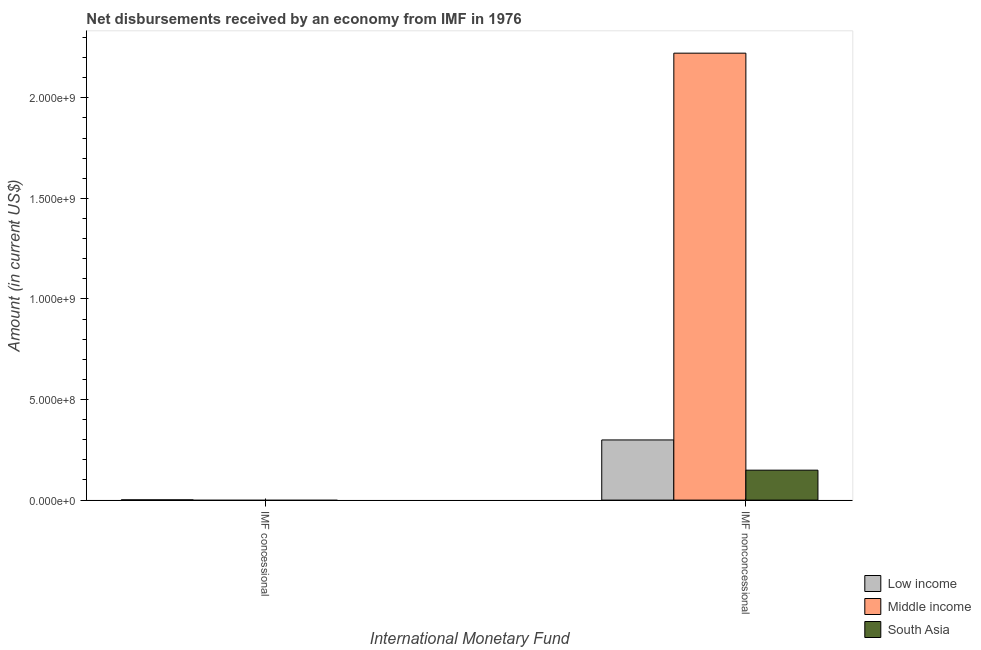How many different coloured bars are there?
Your response must be concise. 3. Are the number of bars on each tick of the X-axis equal?
Provide a short and direct response. No. How many bars are there on the 2nd tick from the left?
Provide a short and direct response. 3. What is the label of the 2nd group of bars from the left?
Provide a succinct answer. IMF nonconcessional. What is the net non concessional disbursements from imf in Middle income?
Offer a terse response. 2.22e+09. Across all countries, what is the maximum net concessional disbursements from imf?
Your answer should be compact. 1.18e+06. What is the total net concessional disbursements from imf in the graph?
Ensure brevity in your answer.  1.18e+06. What is the difference between the net non concessional disbursements from imf in Middle income and that in South Asia?
Give a very brief answer. 2.07e+09. What is the difference between the net non concessional disbursements from imf in Low income and the net concessional disbursements from imf in Middle income?
Make the answer very short. 2.99e+08. What is the average net non concessional disbursements from imf per country?
Keep it short and to the point. 8.90e+08. What is the difference between the net concessional disbursements from imf and net non concessional disbursements from imf in Low income?
Your answer should be compact. -2.98e+08. In how many countries, is the net non concessional disbursements from imf greater than 500000000 US$?
Offer a very short reply. 1. What is the ratio of the net non concessional disbursements from imf in Low income to that in Middle income?
Keep it short and to the point. 0.13. How many bars are there?
Offer a terse response. 4. Are all the bars in the graph horizontal?
Provide a succinct answer. No. How many countries are there in the graph?
Offer a terse response. 3. What is the difference between two consecutive major ticks on the Y-axis?
Give a very brief answer. 5.00e+08. Does the graph contain grids?
Your answer should be very brief. No. What is the title of the graph?
Your answer should be very brief. Net disbursements received by an economy from IMF in 1976. Does "St. Vincent and the Grenadines" appear as one of the legend labels in the graph?
Your answer should be compact. No. What is the label or title of the X-axis?
Make the answer very short. International Monetary Fund. What is the Amount (in current US$) of Low income in IMF concessional?
Offer a terse response. 1.18e+06. What is the Amount (in current US$) in Middle income in IMF concessional?
Provide a short and direct response. 0. What is the Amount (in current US$) of Low income in IMF nonconcessional?
Give a very brief answer. 2.99e+08. What is the Amount (in current US$) of Middle income in IMF nonconcessional?
Provide a short and direct response. 2.22e+09. What is the Amount (in current US$) of South Asia in IMF nonconcessional?
Give a very brief answer. 1.49e+08. Across all International Monetary Fund, what is the maximum Amount (in current US$) in Low income?
Provide a succinct answer. 2.99e+08. Across all International Monetary Fund, what is the maximum Amount (in current US$) of Middle income?
Your answer should be very brief. 2.22e+09. Across all International Monetary Fund, what is the maximum Amount (in current US$) in South Asia?
Provide a short and direct response. 1.49e+08. Across all International Monetary Fund, what is the minimum Amount (in current US$) in Low income?
Keep it short and to the point. 1.18e+06. What is the total Amount (in current US$) in Low income in the graph?
Ensure brevity in your answer.  3.00e+08. What is the total Amount (in current US$) in Middle income in the graph?
Make the answer very short. 2.22e+09. What is the total Amount (in current US$) in South Asia in the graph?
Keep it short and to the point. 1.49e+08. What is the difference between the Amount (in current US$) of Low income in IMF concessional and that in IMF nonconcessional?
Your response must be concise. -2.98e+08. What is the difference between the Amount (in current US$) of Low income in IMF concessional and the Amount (in current US$) of Middle income in IMF nonconcessional?
Make the answer very short. -2.22e+09. What is the difference between the Amount (in current US$) of Low income in IMF concessional and the Amount (in current US$) of South Asia in IMF nonconcessional?
Provide a succinct answer. -1.48e+08. What is the average Amount (in current US$) of Low income per International Monetary Fund?
Your answer should be very brief. 1.50e+08. What is the average Amount (in current US$) in Middle income per International Monetary Fund?
Keep it short and to the point. 1.11e+09. What is the average Amount (in current US$) of South Asia per International Monetary Fund?
Keep it short and to the point. 7.44e+07. What is the difference between the Amount (in current US$) of Low income and Amount (in current US$) of Middle income in IMF nonconcessional?
Offer a terse response. -1.92e+09. What is the difference between the Amount (in current US$) of Low income and Amount (in current US$) of South Asia in IMF nonconcessional?
Give a very brief answer. 1.50e+08. What is the difference between the Amount (in current US$) in Middle income and Amount (in current US$) in South Asia in IMF nonconcessional?
Provide a short and direct response. 2.07e+09. What is the ratio of the Amount (in current US$) of Low income in IMF concessional to that in IMF nonconcessional?
Offer a very short reply. 0. What is the difference between the highest and the second highest Amount (in current US$) of Low income?
Keep it short and to the point. 2.98e+08. What is the difference between the highest and the lowest Amount (in current US$) in Low income?
Your answer should be very brief. 2.98e+08. What is the difference between the highest and the lowest Amount (in current US$) in Middle income?
Make the answer very short. 2.22e+09. What is the difference between the highest and the lowest Amount (in current US$) of South Asia?
Ensure brevity in your answer.  1.49e+08. 